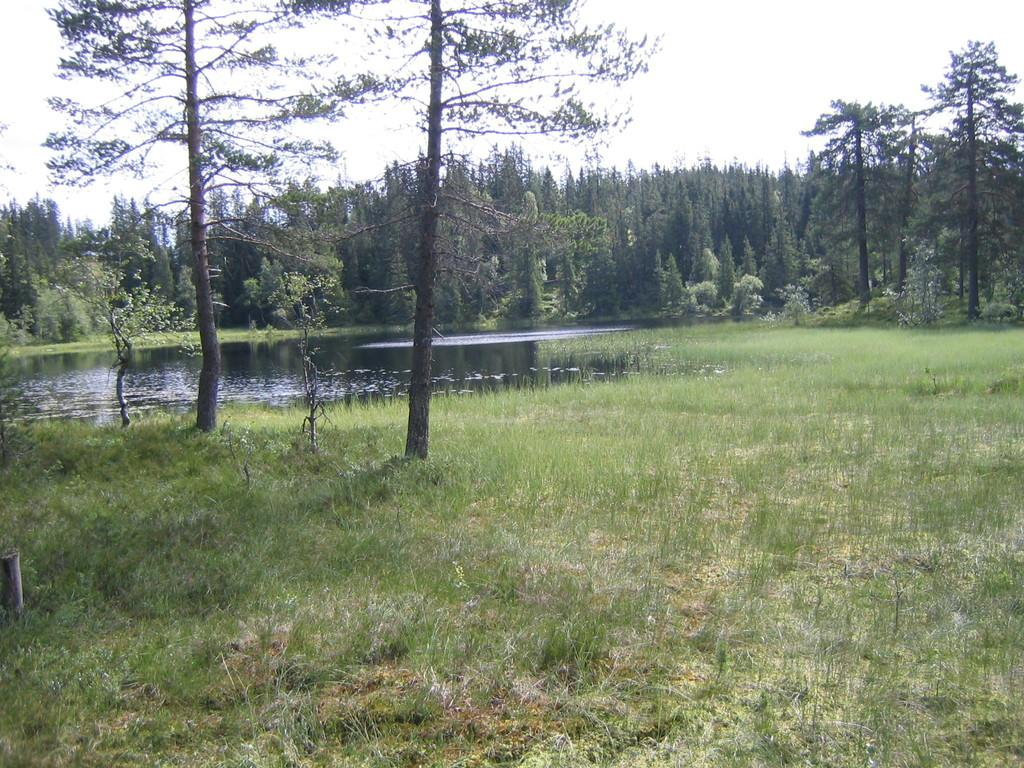What type of vegetation can be seen in the image? There is grass in the image. What else is present in the image besides grass? There is water and trees in the image. What can be seen in the background of the image? The sky is visible behind the trees in the image. Where is the church located in the image? There is no church present in the image. What type of box can be seen near the water in the image? There is no box present in the image. 